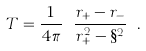<formula> <loc_0><loc_0><loc_500><loc_500>T = \frac { 1 } { 4 \pi } \ \frac { r _ { + } - r _ { - } } { r _ { + } ^ { 2 } - \S ^ { 2 } } \ .</formula> 